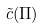<formula> <loc_0><loc_0><loc_500><loc_500>\tilde { c } ( \Pi )</formula> 